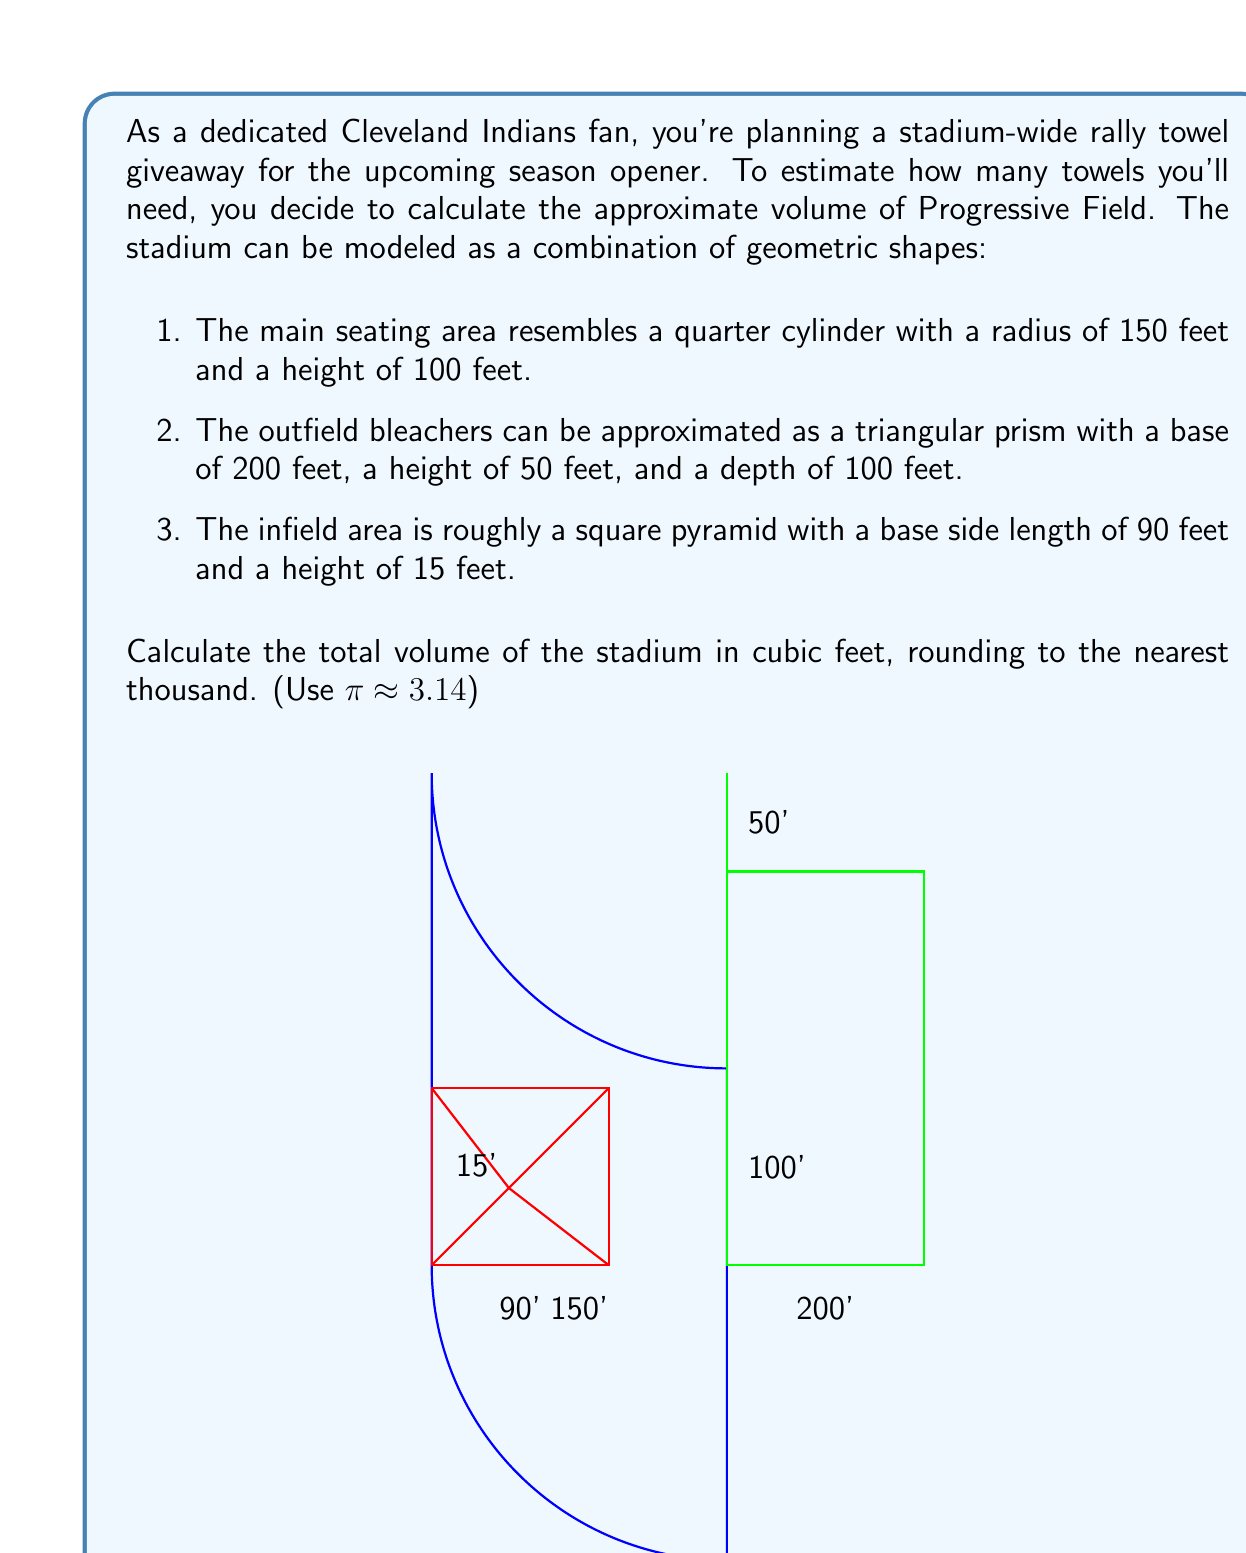Show me your answer to this math problem. Let's calculate the volume of each component separately:

1. Main seating area (quarter cylinder):
   Volume = $\frac{1}{4} \pi r^2 h$
   $V_1 = \frac{1}{4} \cdot 3.14 \cdot 150^2 \cdot 100 = 1,766,250$ cubic feet

2. Outfield bleachers (triangular prism):
   Volume = $\frac{1}{2} \cdot base \cdot height \cdot depth$
   $V_2 = \frac{1}{2} \cdot 200 \cdot 50 \cdot 100 = 500,000$ cubic feet

3. Infield area (square pyramid):
   Volume = $\frac{1}{3} \cdot base\_area \cdot height$
   $V_3 = \frac{1}{3} \cdot 90^2 \cdot 15 = 40,500$ cubic feet

Total volume:
$V_{total} = V_1 + V_2 + V_3$
$V_{total} = 1,766,250 + 500,000 + 40,500 = 2,306,750$ cubic feet

Rounding to the nearest thousand:
$V_{total} \approx 2,307,000$ cubic feet
Answer: 2,307,000 cubic feet 